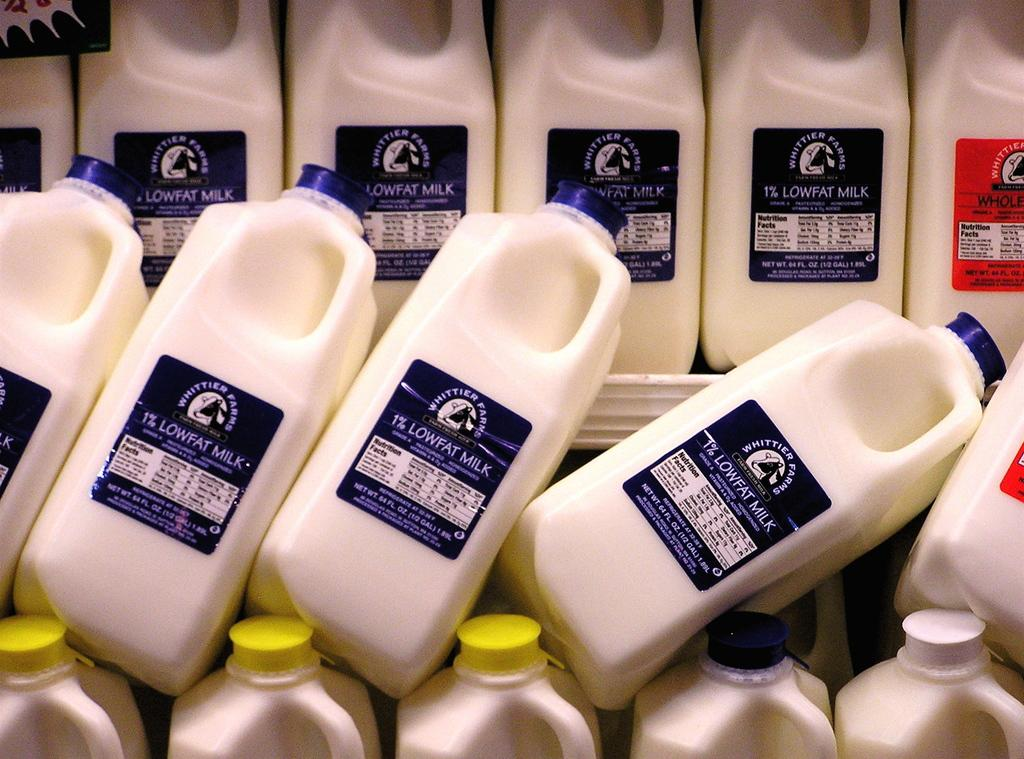Provide a one-sentence caption for the provided image. Lowfat milk cartons on top of one another that are 1%. 